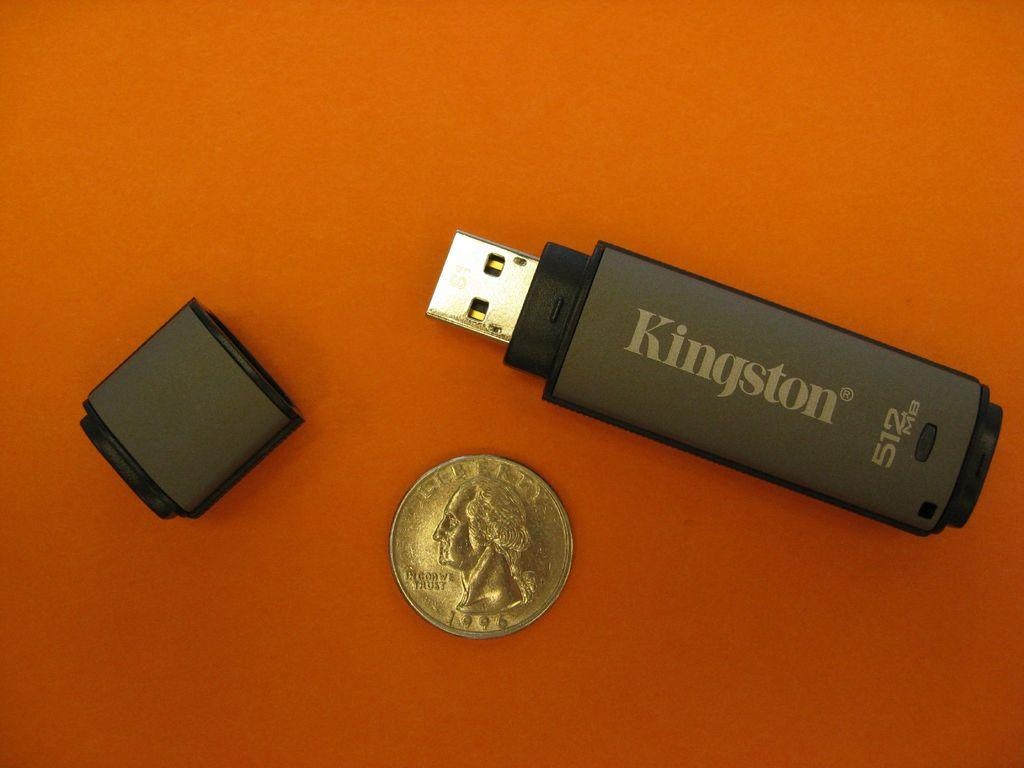<image>
Relay a brief, clear account of the picture shown. A USB memory stick was made by Kingston. 